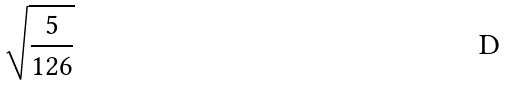Convert formula to latex. <formula><loc_0><loc_0><loc_500><loc_500>\sqrt { \frac { 5 } { 1 2 6 } }</formula> 